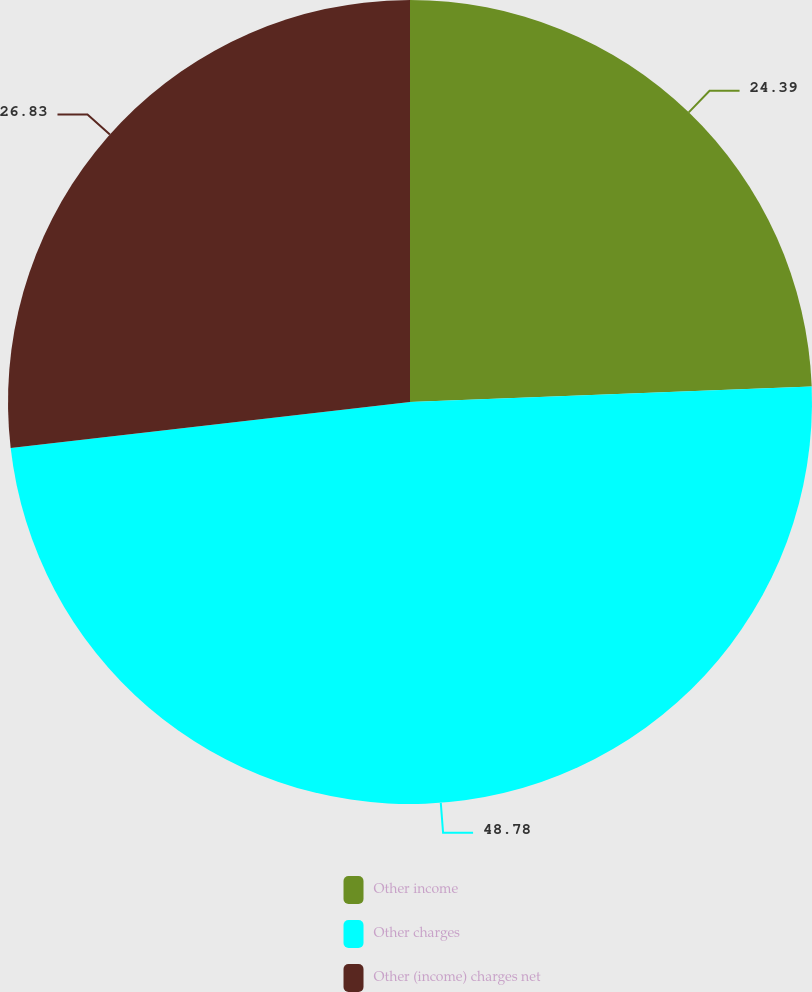<chart> <loc_0><loc_0><loc_500><loc_500><pie_chart><fcel>Other income<fcel>Other charges<fcel>Other (income) charges net<nl><fcel>24.39%<fcel>48.78%<fcel>26.83%<nl></chart> 